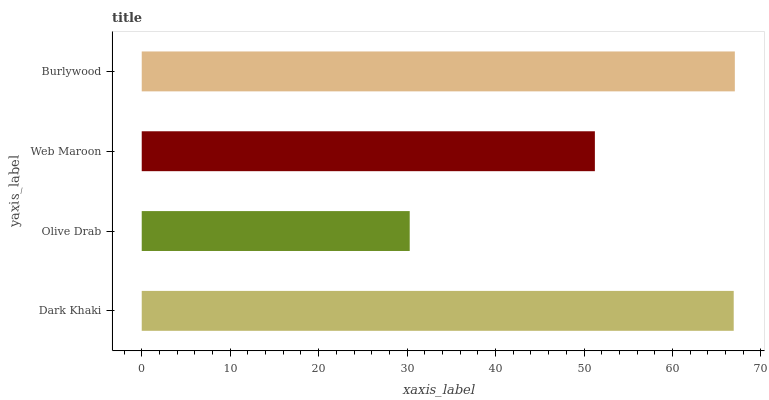Is Olive Drab the minimum?
Answer yes or no. Yes. Is Burlywood the maximum?
Answer yes or no. Yes. Is Web Maroon the minimum?
Answer yes or no. No. Is Web Maroon the maximum?
Answer yes or no. No. Is Web Maroon greater than Olive Drab?
Answer yes or no. Yes. Is Olive Drab less than Web Maroon?
Answer yes or no. Yes. Is Olive Drab greater than Web Maroon?
Answer yes or no. No. Is Web Maroon less than Olive Drab?
Answer yes or no. No. Is Dark Khaki the high median?
Answer yes or no. Yes. Is Web Maroon the low median?
Answer yes or no. Yes. Is Olive Drab the high median?
Answer yes or no. No. Is Olive Drab the low median?
Answer yes or no. No. 